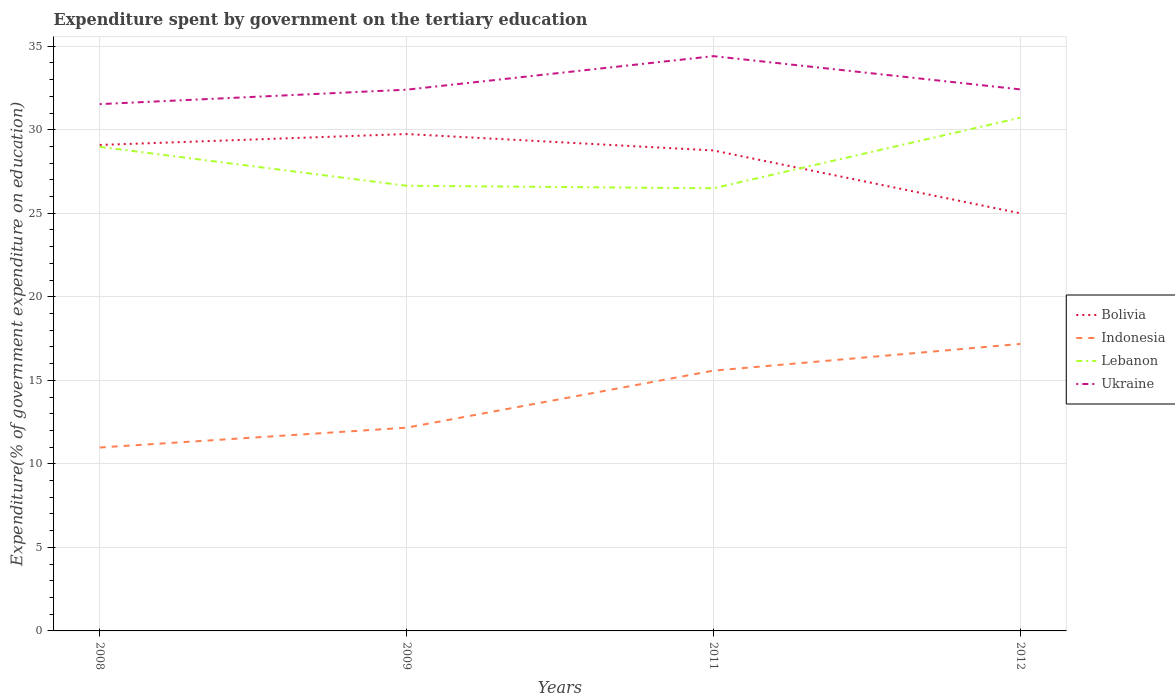Across all years, what is the maximum expenditure spent by government on the tertiary education in Lebanon?
Provide a short and direct response. 26.49. What is the total expenditure spent by government on the tertiary education in Bolivia in the graph?
Offer a terse response. -0.65. What is the difference between the highest and the second highest expenditure spent by government on the tertiary education in Indonesia?
Offer a very short reply. 6.2. How many lines are there?
Keep it short and to the point. 4. How many years are there in the graph?
Your response must be concise. 4. Are the values on the major ticks of Y-axis written in scientific E-notation?
Ensure brevity in your answer.  No. Where does the legend appear in the graph?
Make the answer very short. Center right. What is the title of the graph?
Offer a terse response. Expenditure spent by government on the tertiary education. Does "Djibouti" appear as one of the legend labels in the graph?
Provide a short and direct response. No. What is the label or title of the X-axis?
Your response must be concise. Years. What is the label or title of the Y-axis?
Make the answer very short. Expenditure(% of government expenditure on education). What is the Expenditure(% of government expenditure on education) in Bolivia in 2008?
Your response must be concise. 29.09. What is the Expenditure(% of government expenditure on education) of Indonesia in 2008?
Offer a very short reply. 10.98. What is the Expenditure(% of government expenditure on education) of Lebanon in 2008?
Offer a very short reply. 28.98. What is the Expenditure(% of government expenditure on education) of Ukraine in 2008?
Your answer should be very brief. 31.53. What is the Expenditure(% of government expenditure on education) in Bolivia in 2009?
Your response must be concise. 29.74. What is the Expenditure(% of government expenditure on education) of Indonesia in 2009?
Offer a terse response. 12.17. What is the Expenditure(% of government expenditure on education) of Lebanon in 2009?
Make the answer very short. 26.65. What is the Expenditure(% of government expenditure on education) in Ukraine in 2009?
Keep it short and to the point. 32.4. What is the Expenditure(% of government expenditure on education) in Bolivia in 2011?
Keep it short and to the point. 28.76. What is the Expenditure(% of government expenditure on education) of Indonesia in 2011?
Give a very brief answer. 15.58. What is the Expenditure(% of government expenditure on education) in Lebanon in 2011?
Provide a succinct answer. 26.49. What is the Expenditure(% of government expenditure on education) in Ukraine in 2011?
Your response must be concise. 34.4. What is the Expenditure(% of government expenditure on education) of Bolivia in 2012?
Offer a very short reply. 25. What is the Expenditure(% of government expenditure on education) in Indonesia in 2012?
Your answer should be very brief. 17.18. What is the Expenditure(% of government expenditure on education) in Lebanon in 2012?
Give a very brief answer. 30.72. What is the Expenditure(% of government expenditure on education) of Ukraine in 2012?
Your answer should be compact. 32.41. Across all years, what is the maximum Expenditure(% of government expenditure on education) of Bolivia?
Provide a succinct answer. 29.74. Across all years, what is the maximum Expenditure(% of government expenditure on education) of Indonesia?
Offer a terse response. 17.18. Across all years, what is the maximum Expenditure(% of government expenditure on education) in Lebanon?
Provide a succinct answer. 30.72. Across all years, what is the maximum Expenditure(% of government expenditure on education) in Ukraine?
Ensure brevity in your answer.  34.4. Across all years, what is the minimum Expenditure(% of government expenditure on education) in Bolivia?
Keep it short and to the point. 25. Across all years, what is the minimum Expenditure(% of government expenditure on education) in Indonesia?
Keep it short and to the point. 10.98. Across all years, what is the minimum Expenditure(% of government expenditure on education) of Lebanon?
Offer a very short reply. 26.49. Across all years, what is the minimum Expenditure(% of government expenditure on education) of Ukraine?
Ensure brevity in your answer.  31.53. What is the total Expenditure(% of government expenditure on education) in Bolivia in the graph?
Your answer should be compact. 112.58. What is the total Expenditure(% of government expenditure on education) of Indonesia in the graph?
Give a very brief answer. 55.9. What is the total Expenditure(% of government expenditure on education) in Lebanon in the graph?
Offer a very short reply. 112.83. What is the total Expenditure(% of government expenditure on education) of Ukraine in the graph?
Give a very brief answer. 130.74. What is the difference between the Expenditure(% of government expenditure on education) in Bolivia in 2008 and that in 2009?
Ensure brevity in your answer.  -0.65. What is the difference between the Expenditure(% of government expenditure on education) in Indonesia in 2008 and that in 2009?
Your response must be concise. -1.19. What is the difference between the Expenditure(% of government expenditure on education) in Lebanon in 2008 and that in 2009?
Provide a short and direct response. 2.33. What is the difference between the Expenditure(% of government expenditure on education) of Ukraine in 2008 and that in 2009?
Make the answer very short. -0.86. What is the difference between the Expenditure(% of government expenditure on education) of Bolivia in 2008 and that in 2011?
Provide a succinct answer. 0.33. What is the difference between the Expenditure(% of government expenditure on education) in Indonesia in 2008 and that in 2011?
Provide a short and direct response. -4.6. What is the difference between the Expenditure(% of government expenditure on education) in Lebanon in 2008 and that in 2011?
Provide a succinct answer. 2.48. What is the difference between the Expenditure(% of government expenditure on education) of Ukraine in 2008 and that in 2011?
Your response must be concise. -2.87. What is the difference between the Expenditure(% of government expenditure on education) of Bolivia in 2008 and that in 2012?
Your response must be concise. 4.09. What is the difference between the Expenditure(% of government expenditure on education) in Indonesia in 2008 and that in 2012?
Provide a short and direct response. -6.2. What is the difference between the Expenditure(% of government expenditure on education) of Lebanon in 2008 and that in 2012?
Your answer should be compact. -1.74. What is the difference between the Expenditure(% of government expenditure on education) of Ukraine in 2008 and that in 2012?
Ensure brevity in your answer.  -0.88. What is the difference between the Expenditure(% of government expenditure on education) of Bolivia in 2009 and that in 2011?
Your response must be concise. 0.98. What is the difference between the Expenditure(% of government expenditure on education) of Indonesia in 2009 and that in 2011?
Provide a short and direct response. -3.41. What is the difference between the Expenditure(% of government expenditure on education) in Lebanon in 2009 and that in 2011?
Make the answer very short. 0.15. What is the difference between the Expenditure(% of government expenditure on education) in Ukraine in 2009 and that in 2011?
Keep it short and to the point. -2.01. What is the difference between the Expenditure(% of government expenditure on education) in Bolivia in 2009 and that in 2012?
Provide a short and direct response. 4.74. What is the difference between the Expenditure(% of government expenditure on education) of Indonesia in 2009 and that in 2012?
Your response must be concise. -5.01. What is the difference between the Expenditure(% of government expenditure on education) in Lebanon in 2009 and that in 2012?
Offer a very short reply. -4.07. What is the difference between the Expenditure(% of government expenditure on education) of Ukraine in 2009 and that in 2012?
Ensure brevity in your answer.  -0.02. What is the difference between the Expenditure(% of government expenditure on education) in Bolivia in 2011 and that in 2012?
Offer a very short reply. 3.76. What is the difference between the Expenditure(% of government expenditure on education) in Indonesia in 2011 and that in 2012?
Your response must be concise. -1.6. What is the difference between the Expenditure(% of government expenditure on education) of Lebanon in 2011 and that in 2012?
Offer a terse response. -4.22. What is the difference between the Expenditure(% of government expenditure on education) in Ukraine in 2011 and that in 2012?
Keep it short and to the point. 1.99. What is the difference between the Expenditure(% of government expenditure on education) of Bolivia in 2008 and the Expenditure(% of government expenditure on education) of Indonesia in 2009?
Offer a very short reply. 16.92. What is the difference between the Expenditure(% of government expenditure on education) in Bolivia in 2008 and the Expenditure(% of government expenditure on education) in Lebanon in 2009?
Your response must be concise. 2.44. What is the difference between the Expenditure(% of government expenditure on education) in Bolivia in 2008 and the Expenditure(% of government expenditure on education) in Ukraine in 2009?
Provide a succinct answer. -3.31. What is the difference between the Expenditure(% of government expenditure on education) of Indonesia in 2008 and the Expenditure(% of government expenditure on education) of Lebanon in 2009?
Offer a terse response. -15.67. What is the difference between the Expenditure(% of government expenditure on education) in Indonesia in 2008 and the Expenditure(% of government expenditure on education) in Ukraine in 2009?
Your answer should be very brief. -21.42. What is the difference between the Expenditure(% of government expenditure on education) of Lebanon in 2008 and the Expenditure(% of government expenditure on education) of Ukraine in 2009?
Keep it short and to the point. -3.42. What is the difference between the Expenditure(% of government expenditure on education) in Bolivia in 2008 and the Expenditure(% of government expenditure on education) in Indonesia in 2011?
Offer a very short reply. 13.51. What is the difference between the Expenditure(% of government expenditure on education) of Bolivia in 2008 and the Expenditure(% of government expenditure on education) of Lebanon in 2011?
Make the answer very short. 2.59. What is the difference between the Expenditure(% of government expenditure on education) of Bolivia in 2008 and the Expenditure(% of government expenditure on education) of Ukraine in 2011?
Your answer should be compact. -5.32. What is the difference between the Expenditure(% of government expenditure on education) of Indonesia in 2008 and the Expenditure(% of government expenditure on education) of Lebanon in 2011?
Give a very brief answer. -15.52. What is the difference between the Expenditure(% of government expenditure on education) of Indonesia in 2008 and the Expenditure(% of government expenditure on education) of Ukraine in 2011?
Provide a succinct answer. -23.43. What is the difference between the Expenditure(% of government expenditure on education) of Lebanon in 2008 and the Expenditure(% of government expenditure on education) of Ukraine in 2011?
Your response must be concise. -5.43. What is the difference between the Expenditure(% of government expenditure on education) of Bolivia in 2008 and the Expenditure(% of government expenditure on education) of Indonesia in 2012?
Offer a very short reply. 11.91. What is the difference between the Expenditure(% of government expenditure on education) in Bolivia in 2008 and the Expenditure(% of government expenditure on education) in Lebanon in 2012?
Give a very brief answer. -1.63. What is the difference between the Expenditure(% of government expenditure on education) of Bolivia in 2008 and the Expenditure(% of government expenditure on education) of Ukraine in 2012?
Ensure brevity in your answer.  -3.33. What is the difference between the Expenditure(% of government expenditure on education) in Indonesia in 2008 and the Expenditure(% of government expenditure on education) in Lebanon in 2012?
Your response must be concise. -19.74. What is the difference between the Expenditure(% of government expenditure on education) in Indonesia in 2008 and the Expenditure(% of government expenditure on education) in Ukraine in 2012?
Your answer should be very brief. -21.43. What is the difference between the Expenditure(% of government expenditure on education) in Lebanon in 2008 and the Expenditure(% of government expenditure on education) in Ukraine in 2012?
Provide a succinct answer. -3.44. What is the difference between the Expenditure(% of government expenditure on education) in Bolivia in 2009 and the Expenditure(% of government expenditure on education) in Indonesia in 2011?
Your answer should be very brief. 14.16. What is the difference between the Expenditure(% of government expenditure on education) in Bolivia in 2009 and the Expenditure(% of government expenditure on education) in Lebanon in 2011?
Make the answer very short. 3.25. What is the difference between the Expenditure(% of government expenditure on education) of Bolivia in 2009 and the Expenditure(% of government expenditure on education) of Ukraine in 2011?
Offer a very short reply. -4.66. What is the difference between the Expenditure(% of government expenditure on education) in Indonesia in 2009 and the Expenditure(% of government expenditure on education) in Lebanon in 2011?
Your answer should be compact. -14.33. What is the difference between the Expenditure(% of government expenditure on education) of Indonesia in 2009 and the Expenditure(% of government expenditure on education) of Ukraine in 2011?
Make the answer very short. -22.24. What is the difference between the Expenditure(% of government expenditure on education) in Lebanon in 2009 and the Expenditure(% of government expenditure on education) in Ukraine in 2011?
Provide a short and direct response. -7.76. What is the difference between the Expenditure(% of government expenditure on education) in Bolivia in 2009 and the Expenditure(% of government expenditure on education) in Indonesia in 2012?
Offer a terse response. 12.56. What is the difference between the Expenditure(% of government expenditure on education) of Bolivia in 2009 and the Expenditure(% of government expenditure on education) of Lebanon in 2012?
Ensure brevity in your answer.  -0.98. What is the difference between the Expenditure(% of government expenditure on education) of Bolivia in 2009 and the Expenditure(% of government expenditure on education) of Ukraine in 2012?
Keep it short and to the point. -2.67. What is the difference between the Expenditure(% of government expenditure on education) of Indonesia in 2009 and the Expenditure(% of government expenditure on education) of Lebanon in 2012?
Your answer should be very brief. -18.55. What is the difference between the Expenditure(% of government expenditure on education) in Indonesia in 2009 and the Expenditure(% of government expenditure on education) in Ukraine in 2012?
Make the answer very short. -20.25. What is the difference between the Expenditure(% of government expenditure on education) in Lebanon in 2009 and the Expenditure(% of government expenditure on education) in Ukraine in 2012?
Keep it short and to the point. -5.77. What is the difference between the Expenditure(% of government expenditure on education) of Bolivia in 2011 and the Expenditure(% of government expenditure on education) of Indonesia in 2012?
Provide a short and direct response. 11.58. What is the difference between the Expenditure(% of government expenditure on education) of Bolivia in 2011 and the Expenditure(% of government expenditure on education) of Lebanon in 2012?
Offer a terse response. -1.96. What is the difference between the Expenditure(% of government expenditure on education) of Bolivia in 2011 and the Expenditure(% of government expenditure on education) of Ukraine in 2012?
Provide a short and direct response. -3.65. What is the difference between the Expenditure(% of government expenditure on education) of Indonesia in 2011 and the Expenditure(% of government expenditure on education) of Lebanon in 2012?
Your answer should be compact. -15.14. What is the difference between the Expenditure(% of government expenditure on education) of Indonesia in 2011 and the Expenditure(% of government expenditure on education) of Ukraine in 2012?
Your answer should be very brief. -16.83. What is the difference between the Expenditure(% of government expenditure on education) of Lebanon in 2011 and the Expenditure(% of government expenditure on education) of Ukraine in 2012?
Give a very brief answer. -5.92. What is the average Expenditure(% of government expenditure on education) of Bolivia per year?
Ensure brevity in your answer.  28.15. What is the average Expenditure(% of government expenditure on education) of Indonesia per year?
Keep it short and to the point. 13.98. What is the average Expenditure(% of government expenditure on education) in Lebanon per year?
Provide a short and direct response. 28.21. What is the average Expenditure(% of government expenditure on education) of Ukraine per year?
Ensure brevity in your answer.  32.69. In the year 2008, what is the difference between the Expenditure(% of government expenditure on education) of Bolivia and Expenditure(% of government expenditure on education) of Indonesia?
Provide a short and direct response. 18.11. In the year 2008, what is the difference between the Expenditure(% of government expenditure on education) of Bolivia and Expenditure(% of government expenditure on education) of Lebanon?
Your response must be concise. 0.11. In the year 2008, what is the difference between the Expenditure(% of government expenditure on education) of Bolivia and Expenditure(% of government expenditure on education) of Ukraine?
Ensure brevity in your answer.  -2.44. In the year 2008, what is the difference between the Expenditure(% of government expenditure on education) in Indonesia and Expenditure(% of government expenditure on education) in Lebanon?
Give a very brief answer. -18. In the year 2008, what is the difference between the Expenditure(% of government expenditure on education) of Indonesia and Expenditure(% of government expenditure on education) of Ukraine?
Offer a terse response. -20.55. In the year 2008, what is the difference between the Expenditure(% of government expenditure on education) in Lebanon and Expenditure(% of government expenditure on education) in Ukraine?
Your answer should be very brief. -2.56. In the year 2009, what is the difference between the Expenditure(% of government expenditure on education) of Bolivia and Expenditure(% of government expenditure on education) of Indonesia?
Your response must be concise. 17.58. In the year 2009, what is the difference between the Expenditure(% of government expenditure on education) of Bolivia and Expenditure(% of government expenditure on education) of Lebanon?
Your response must be concise. 3.09. In the year 2009, what is the difference between the Expenditure(% of government expenditure on education) of Bolivia and Expenditure(% of government expenditure on education) of Ukraine?
Make the answer very short. -2.66. In the year 2009, what is the difference between the Expenditure(% of government expenditure on education) of Indonesia and Expenditure(% of government expenditure on education) of Lebanon?
Offer a very short reply. -14.48. In the year 2009, what is the difference between the Expenditure(% of government expenditure on education) in Indonesia and Expenditure(% of government expenditure on education) in Ukraine?
Your answer should be compact. -20.23. In the year 2009, what is the difference between the Expenditure(% of government expenditure on education) in Lebanon and Expenditure(% of government expenditure on education) in Ukraine?
Your answer should be compact. -5.75. In the year 2011, what is the difference between the Expenditure(% of government expenditure on education) in Bolivia and Expenditure(% of government expenditure on education) in Indonesia?
Offer a very short reply. 13.18. In the year 2011, what is the difference between the Expenditure(% of government expenditure on education) of Bolivia and Expenditure(% of government expenditure on education) of Lebanon?
Offer a terse response. 2.26. In the year 2011, what is the difference between the Expenditure(% of government expenditure on education) of Bolivia and Expenditure(% of government expenditure on education) of Ukraine?
Offer a very short reply. -5.64. In the year 2011, what is the difference between the Expenditure(% of government expenditure on education) in Indonesia and Expenditure(% of government expenditure on education) in Lebanon?
Ensure brevity in your answer.  -10.92. In the year 2011, what is the difference between the Expenditure(% of government expenditure on education) in Indonesia and Expenditure(% of government expenditure on education) in Ukraine?
Offer a very short reply. -18.82. In the year 2011, what is the difference between the Expenditure(% of government expenditure on education) of Lebanon and Expenditure(% of government expenditure on education) of Ukraine?
Provide a short and direct response. -7.91. In the year 2012, what is the difference between the Expenditure(% of government expenditure on education) in Bolivia and Expenditure(% of government expenditure on education) in Indonesia?
Make the answer very short. 7.82. In the year 2012, what is the difference between the Expenditure(% of government expenditure on education) in Bolivia and Expenditure(% of government expenditure on education) in Lebanon?
Your response must be concise. -5.72. In the year 2012, what is the difference between the Expenditure(% of government expenditure on education) of Bolivia and Expenditure(% of government expenditure on education) of Ukraine?
Your response must be concise. -7.42. In the year 2012, what is the difference between the Expenditure(% of government expenditure on education) of Indonesia and Expenditure(% of government expenditure on education) of Lebanon?
Make the answer very short. -13.54. In the year 2012, what is the difference between the Expenditure(% of government expenditure on education) in Indonesia and Expenditure(% of government expenditure on education) in Ukraine?
Offer a very short reply. -15.23. In the year 2012, what is the difference between the Expenditure(% of government expenditure on education) in Lebanon and Expenditure(% of government expenditure on education) in Ukraine?
Make the answer very short. -1.7. What is the ratio of the Expenditure(% of government expenditure on education) of Indonesia in 2008 to that in 2009?
Provide a succinct answer. 0.9. What is the ratio of the Expenditure(% of government expenditure on education) of Lebanon in 2008 to that in 2009?
Ensure brevity in your answer.  1.09. What is the ratio of the Expenditure(% of government expenditure on education) in Ukraine in 2008 to that in 2009?
Your response must be concise. 0.97. What is the ratio of the Expenditure(% of government expenditure on education) of Bolivia in 2008 to that in 2011?
Offer a terse response. 1.01. What is the ratio of the Expenditure(% of government expenditure on education) of Indonesia in 2008 to that in 2011?
Keep it short and to the point. 0.7. What is the ratio of the Expenditure(% of government expenditure on education) of Lebanon in 2008 to that in 2011?
Offer a terse response. 1.09. What is the ratio of the Expenditure(% of government expenditure on education) in Ukraine in 2008 to that in 2011?
Offer a very short reply. 0.92. What is the ratio of the Expenditure(% of government expenditure on education) in Bolivia in 2008 to that in 2012?
Ensure brevity in your answer.  1.16. What is the ratio of the Expenditure(% of government expenditure on education) of Indonesia in 2008 to that in 2012?
Keep it short and to the point. 0.64. What is the ratio of the Expenditure(% of government expenditure on education) in Lebanon in 2008 to that in 2012?
Your response must be concise. 0.94. What is the ratio of the Expenditure(% of government expenditure on education) of Ukraine in 2008 to that in 2012?
Offer a terse response. 0.97. What is the ratio of the Expenditure(% of government expenditure on education) of Bolivia in 2009 to that in 2011?
Offer a very short reply. 1.03. What is the ratio of the Expenditure(% of government expenditure on education) in Indonesia in 2009 to that in 2011?
Ensure brevity in your answer.  0.78. What is the ratio of the Expenditure(% of government expenditure on education) in Lebanon in 2009 to that in 2011?
Offer a very short reply. 1.01. What is the ratio of the Expenditure(% of government expenditure on education) of Ukraine in 2009 to that in 2011?
Provide a succinct answer. 0.94. What is the ratio of the Expenditure(% of government expenditure on education) of Bolivia in 2009 to that in 2012?
Provide a succinct answer. 1.19. What is the ratio of the Expenditure(% of government expenditure on education) of Indonesia in 2009 to that in 2012?
Your response must be concise. 0.71. What is the ratio of the Expenditure(% of government expenditure on education) in Lebanon in 2009 to that in 2012?
Offer a terse response. 0.87. What is the ratio of the Expenditure(% of government expenditure on education) in Bolivia in 2011 to that in 2012?
Give a very brief answer. 1.15. What is the ratio of the Expenditure(% of government expenditure on education) of Indonesia in 2011 to that in 2012?
Your answer should be very brief. 0.91. What is the ratio of the Expenditure(% of government expenditure on education) in Lebanon in 2011 to that in 2012?
Your answer should be very brief. 0.86. What is the ratio of the Expenditure(% of government expenditure on education) of Ukraine in 2011 to that in 2012?
Keep it short and to the point. 1.06. What is the difference between the highest and the second highest Expenditure(% of government expenditure on education) in Bolivia?
Keep it short and to the point. 0.65. What is the difference between the highest and the second highest Expenditure(% of government expenditure on education) in Indonesia?
Your response must be concise. 1.6. What is the difference between the highest and the second highest Expenditure(% of government expenditure on education) in Lebanon?
Make the answer very short. 1.74. What is the difference between the highest and the second highest Expenditure(% of government expenditure on education) in Ukraine?
Make the answer very short. 1.99. What is the difference between the highest and the lowest Expenditure(% of government expenditure on education) of Bolivia?
Your response must be concise. 4.74. What is the difference between the highest and the lowest Expenditure(% of government expenditure on education) of Indonesia?
Ensure brevity in your answer.  6.2. What is the difference between the highest and the lowest Expenditure(% of government expenditure on education) in Lebanon?
Your answer should be compact. 4.22. What is the difference between the highest and the lowest Expenditure(% of government expenditure on education) in Ukraine?
Give a very brief answer. 2.87. 